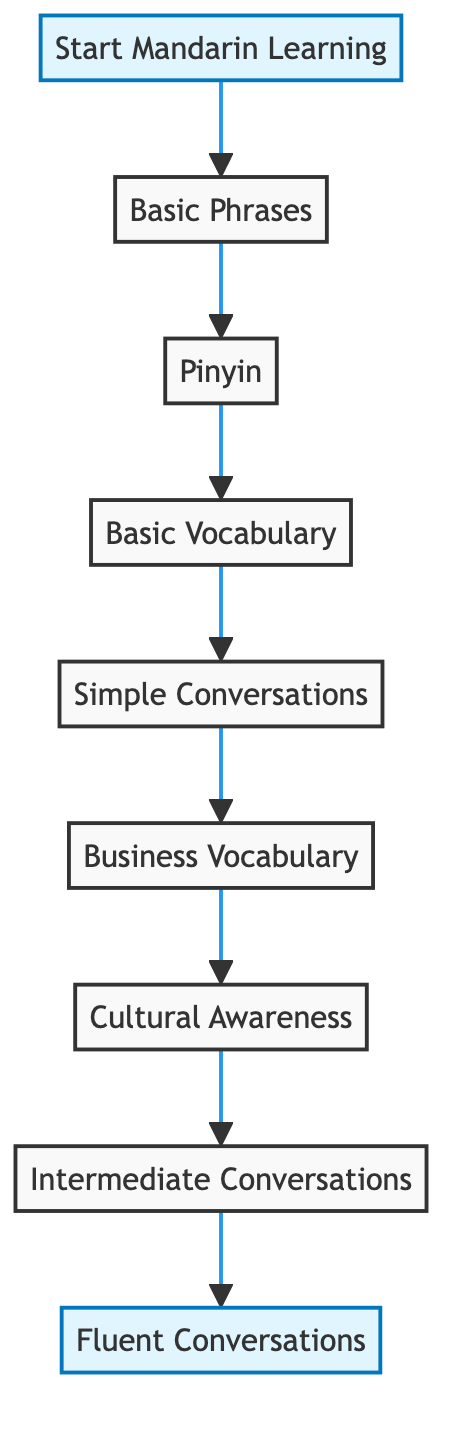what is the first milestone in learning Mandarin? The first milestone is represented by the "Start Mandarin Learning" node, which indicates the beginning of structured lessons.
Answer: Start Mandarin Learning how many total nodes are present in the diagram? The diagram shows a total of 8 nodes, each representing a different milestone or aspect of Mandarin learning.
Answer: 8 what is the last milestone in the learning process? The last milestone is depicted as "Fluent Conversations," signifying the achievement of fluency in conversations.
Answer: Fluent Conversations which two milestones come before "Business Vocabulary"? The two milestones preceding "Business Vocabulary" are "Simple Conversations" and "Basic Vocabulary," as per the directed connections in the diagram.
Answer: Simple Conversations, Basic Vocabulary what is the relationship between "Cultural Awareness" and "Intermediate Conversations"? The relationship is that "Cultural Awareness" directs to "Intermediate Conversations," indicating that understanding cultural nuances is essential before engaging in intermediate-level dialogues.
Answer: Cultural Awareness leads to Intermediate Conversations how many edges connect the nodes in the diagram? The diagram includes 8 edges, each representing a direct connection from one learning milestone to the next in the structured process.
Answer: 8 which milestone involves learning industry-specific terms? The milestone that involves this is labeled "Business Vocabulary," which focuses on language pertinent to specific industries.
Answer: Business Vocabulary what milestone directly follows "Pinyin"? The milestone that directly follows "Pinyin" in the flow is "Basic Vocabulary," indicating progression in learning after understanding phonetic notation.
Answer: Basic Vocabulary 